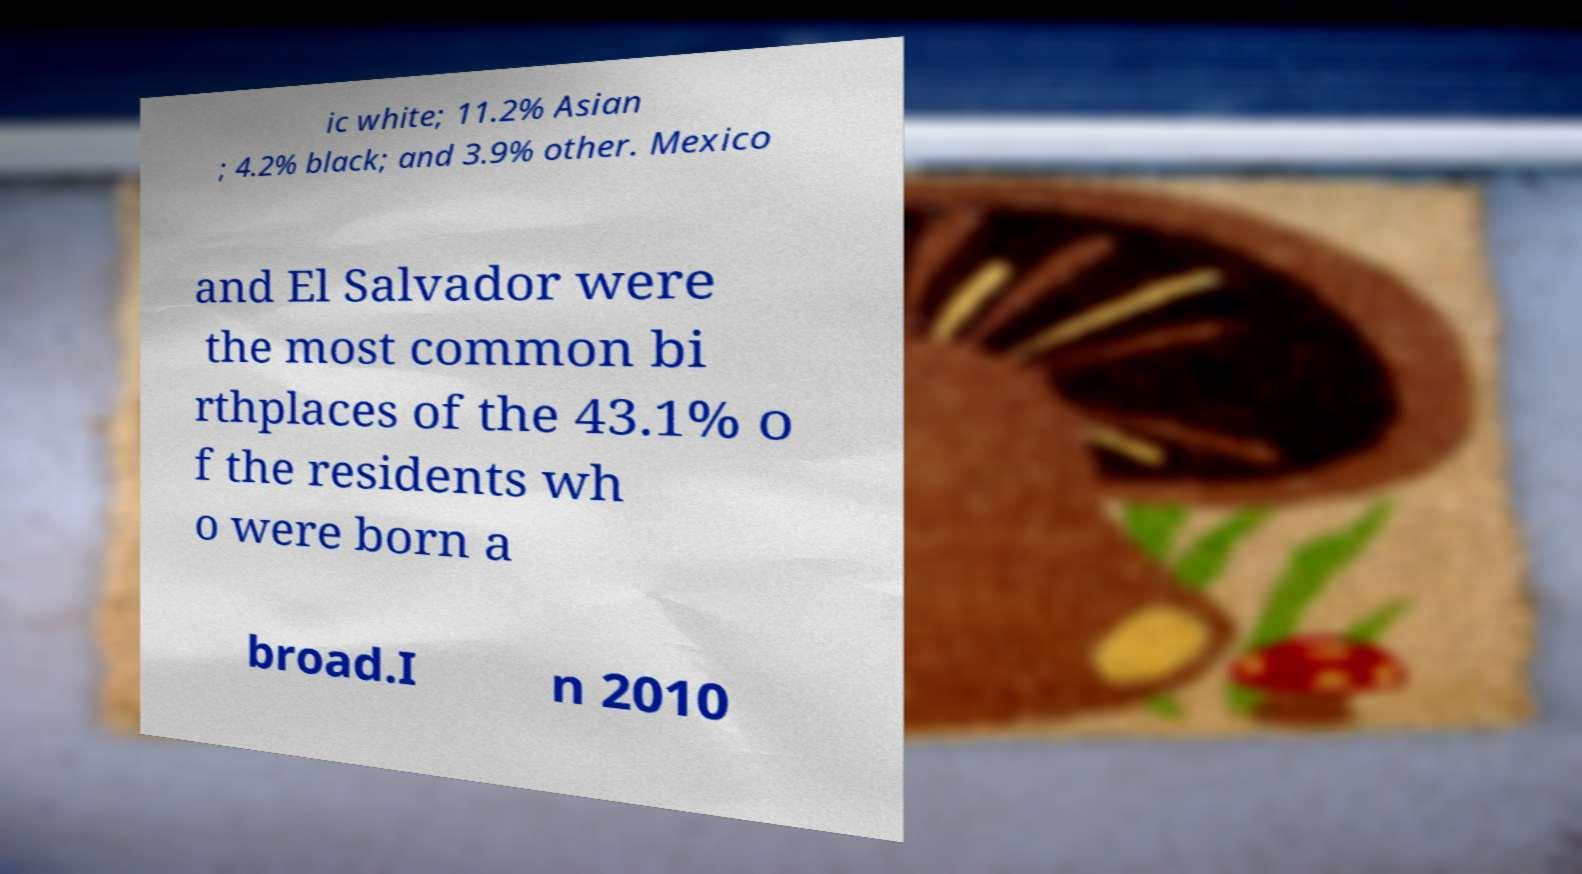Could you extract and type out the text from this image? ic white; 11.2% Asian ; 4.2% black; and 3.9% other. Mexico and El Salvador were the most common bi rthplaces of the 43.1% o f the residents wh o were born a broad.I n 2010 